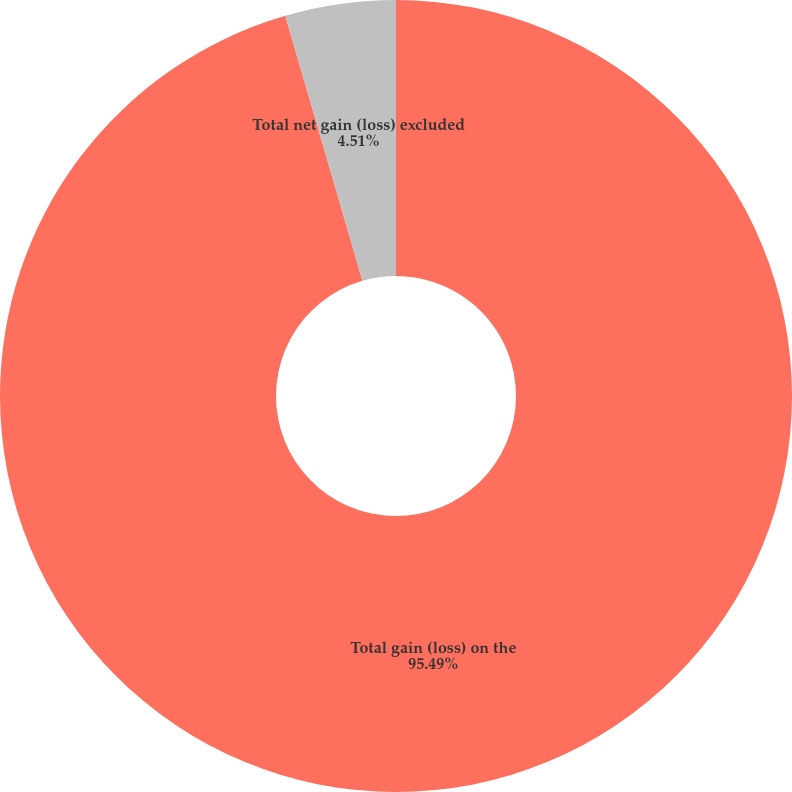Convert chart. <chart><loc_0><loc_0><loc_500><loc_500><pie_chart><fcel>Total gain (loss) on the<fcel>Total net gain (loss) excluded<nl><fcel>95.49%<fcel>4.51%<nl></chart> 